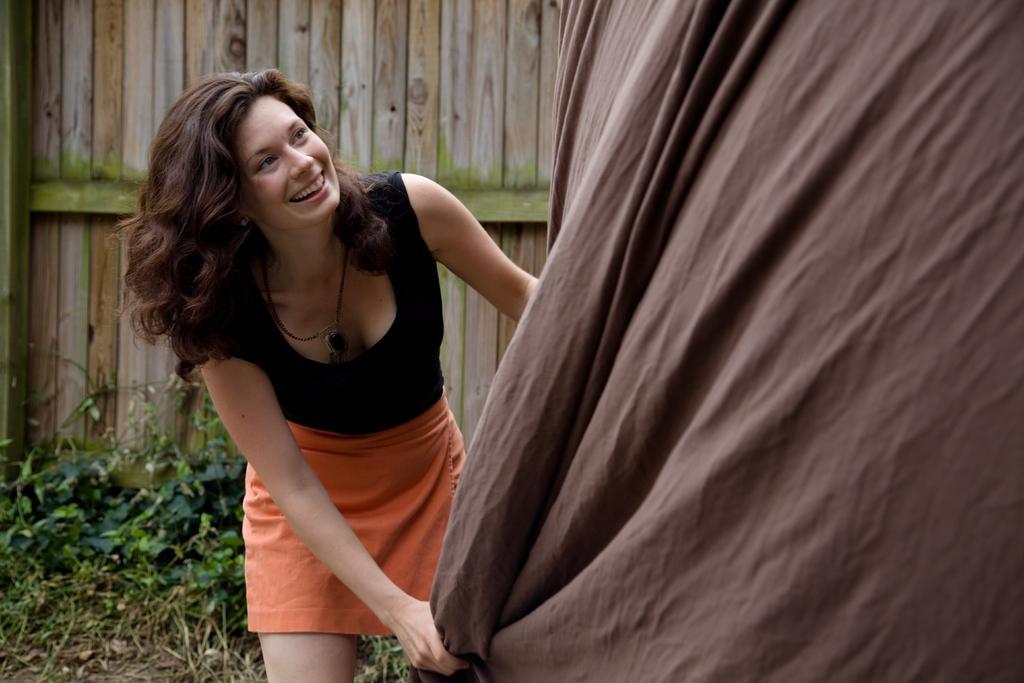In one or two sentences, can you explain what this image depicts? There is a lady in the center of the image. In the background of the image there is a wooden wall. There are plants. 